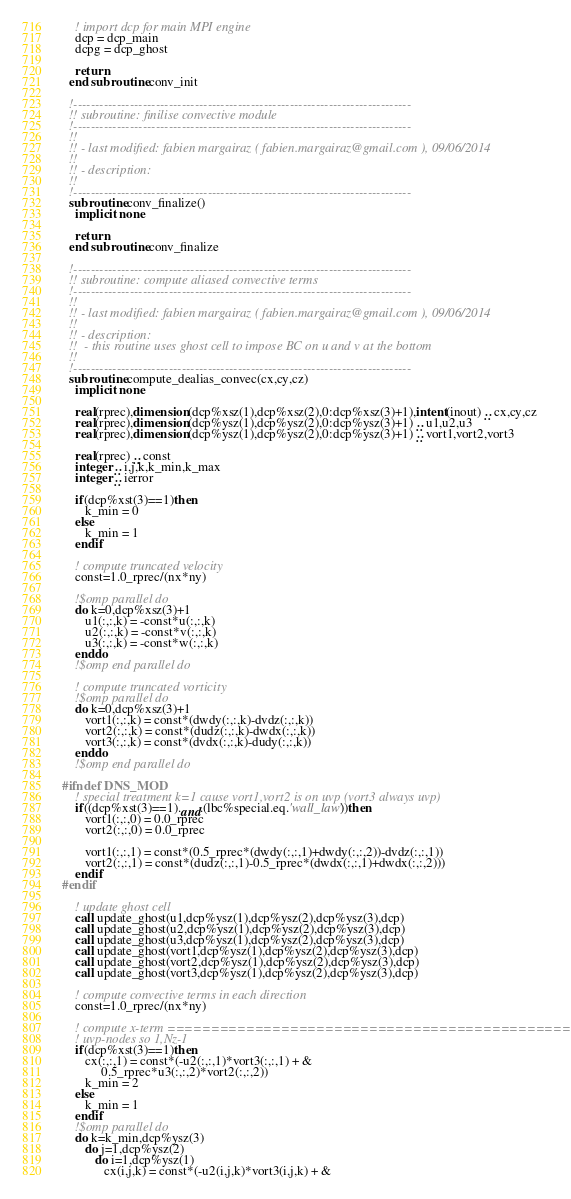Convert code to text. <code><loc_0><loc_0><loc_500><loc_500><_FORTRAN_>
    ! import dcp for main MPI engine
    dcp = dcp_main
    dcpg = dcp_ghost
   
    return
  end subroutine conv_init

  !------------------------------------------------------------------------------
  !! subroutine: finilise convective module
  !------------------------------------------------------------------------------
  !!
  !! - last modified: fabien margairaz ( fabien.margairaz@gmail.com ), 09/06/2014
  !!
  !! - description:
  !!
  !------------------------------------------------------------------------------
  subroutine conv_finalize() 
    implicit none
    
    return
  end subroutine conv_finalize

  !------------------------------------------------------------------------------
  !! subroutine: compute aliased convective terms
  !------------------------------------------------------------------------------
  !!
  !! - last modified: fabien margairaz ( fabien.margairaz@gmail.com ), 09/06/2014
  !!
  !! - description:
  !!  - this routine uses ghost cell to impose BC on u and v at the bottom
  !!
  !------------------------------------------------------------------------------
  subroutine compute_dealias_convec(cx,cy,cz) 
    implicit none
    
    real(rprec),dimension(dcp%xsz(1),dcp%xsz(2),0:dcp%xsz(3)+1),intent(inout) :: cx,cy,cz
    real(rprec),dimension(dcp%ysz(1),dcp%ysz(2),0:dcp%ysz(3)+1) :: u1,u2,u3
    real(rprec),dimension(dcp%ysz(1),dcp%ysz(2),0:dcp%ysz(3)+1) :: vort1,vort2,vort3

    real(rprec) :: const
    integer :: i,j,k,k_min,k_max
    integer :: ierror

    if(dcp%xst(3)==1)then
       k_min = 0
    else
       k_min = 1
    endif

    ! compute truncated velocity
    const=1.0_rprec/(nx*ny)

    !$omp parallel do
    do k=0,dcp%xsz(3)+1
       u1(:,:,k) = -const*u(:,:,k)
       u2(:,:,k) = -const*v(:,:,k)
       u3(:,:,k) = -const*w(:,:,k)
    enddo
    !$omp end parallel do
    
    ! compute truncated vorticity
    !$omp parallel do
    do k=0,dcp%xsz(3)+1
       vort1(:,:,k) = const*(dwdy(:,:,k)-dvdz(:,:,k))
       vort2(:,:,k) = const*(dudz(:,:,k)-dwdx(:,:,k))
       vort3(:,:,k) = const*(dvdx(:,:,k)-dudy(:,:,k))
    enddo
    !$omp end parallel do    

#ifndef DNS_MOD
    ! special treatment k=1 cause vort1,vort2 is on uvp (vort3 always uvp)
    if((dcp%xst(3)==1).and.(lbc%special.eq.'wall_law'))then
       vort1(:,:,0) = 0.0_rprec
       vort2(:,:,0) = 0.0_rprec

       vort1(:,:,1) = const*(0.5_rprec*(dwdy(:,:,1)+dwdy(:,:,2))-dvdz(:,:,1))      
       vort2(:,:,1) = const*(dudz(:,:,1)-0.5_rprec*(dwdx(:,:,1)+dwdx(:,:,2)))
    endif
#endif

    ! update ghost cell
    call update_ghost(u1,dcp%ysz(1),dcp%ysz(2),dcp%ysz(3),dcp)
    call update_ghost(u2,dcp%ysz(1),dcp%ysz(2),dcp%ysz(3),dcp)
    call update_ghost(u3,dcp%ysz(1),dcp%ysz(2),dcp%ysz(3),dcp)
    call update_ghost(vort1,dcp%ysz(1),dcp%ysz(2),dcp%ysz(3),dcp)
    call update_ghost(vort2,dcp%ysz(1),dcp%ysz(2),dcp%ysz(3),dcp)
    call update_ghost(vort3,dcp%ysz(1),dcp%ysz(2),dcp%ysz(3),dcp)

    ! compute convective terms in each direction
    const=1.0_rprec/(nx*ny)

    ! compute x-term ====================================================
    ! uvp-nodes so 1,Nz-1
    if(dcp%xst(3)==1)then
       cx(:,:,1) = const*(-u2(:,:,1)*vort3(:,:,1) + &
            0.5_rprec*u3(:,:,2)*vort2(:,:,2))
       k_min = 2
    else
       k_min = 1
    endif
    !$omp parallel do
    do k=k_min,dcp%ysz(3)
       do j=1,dcp%ysz(2)
          do i=1,dcp%ysz(1)
             cx(i,j,k) = const*(-u2(i,j,k)*vort3(i,j,k) + &</code> 